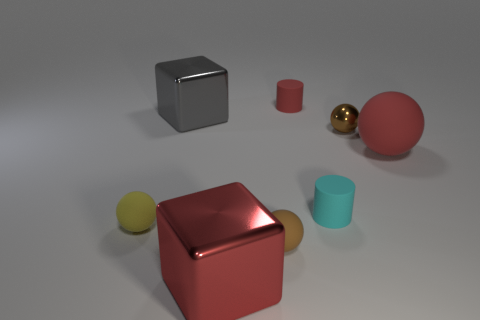Subtract all small metal spheres. How many spheres are left? 3 Add 1 red objects. How many objects exist? 9 Subtract all red balls. How many balls are left? 3 Subtract 0 green balls. How many objects are left? 8 Subtract all blocks. How many objects are left? 6 Subtract 1 cubes. How many cubes are left? 1 Subtract all brown cubes. Subtract all green spheres. How many cubes are left? 2 Subtract all green spheres. How many cyan blocks are left? 0 Subtract all green matte cylinders. Subtract all large gray shiny cubes. How many objects are left? 7 Add 5 small cylinders. How many small cylinders are left? 7 